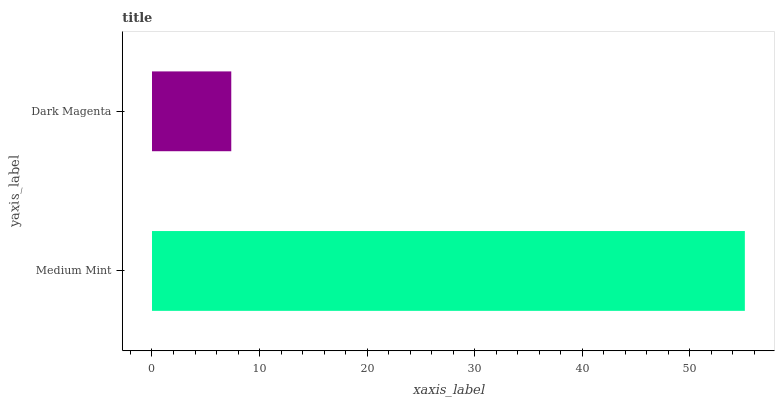Is Dark Magenta the minimum?
Answer yes or no. Yes. Is Medium Mint the maximum?
Answer yes or no. Yes. Is Dark Magenta the maximum?
Answer yes or no. No. Is Medium Mint greater than Dark Magenta?
Answer yes or no. Yes. Is Dark Magenta less than Medium Mint?
Answer yes or no. Yes. Is Dark Magenta greater than Medium Mint?
Answer yes or no. No. Is Medium Mint less than Dark Magenta?
Answer yes or no. No. Is Medium Mint the high median?
Answer yes or no. Yes. Is Dark Magenta the low median?
Answer yes or no. Yes. Is Dark Magenta the high median?
Answer yes or no. No. Is Medium Mint the low median?
Answer yes or no. No. 